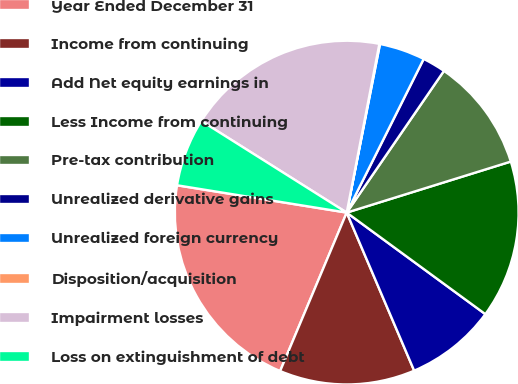Convert chart. <chart><loc_0><loc_0><loc_500><loc_500><pie_chart><fcel>Year Ended December 31<fcel>Income from continuing<fcel>Add Net equity earnings in<fcel>Less Income from continuing<fcel>Pre-tax contribution<fcel>Unrealized derivative gains<fcel>Unrealized foreign currency<fcel>Disposition/acquisition<fcel>Impairment losses<fcel>Loss on extinguishment of debt<nl><fcel>21.21%<fcel>12.75%<fcel>8.52%<fcel>14.86%<fcel>10.63%<fcel>2.18%<fcel>4.29%<fcel>0.06%<fcel>19.09%<fcel>6.41%<nl></chart> 